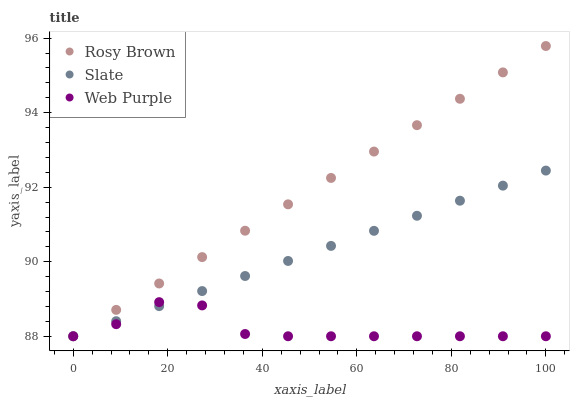Does Web Purple have the minimum area under the curve?
Answer yes or no. Yes. Does Rosy Brown have the maximum area under the curve?
Answer yes or no. Yes. Does Rosy Brown have the minimum area under the curve?
Answer yes or no. No. Does Web Purple have the maximum area under the curve?
Answer yes or no. No. Is Rosy Brown the smoothest?
Answer yes or no. Yes. Is Web Purple the roughest?
Answer yes or no. Yes. Is Web Purple the smoothest?
Answer yes or no. No. Is Rosy Brown the roughest?
Answer yes or no. No. Does Slate have the lowest value?
Answer yes or no. Yes. Does Rosy Brown have the highest value?
Answer yes or no. Yes. Does Web Purple have the highest value?
Answer yes or no. No. Does Rosy Brown intersect Web Purple?
Answer yes or no. Yes. Is Rosy Brown less than Web Purple?
Answer yes or no. No. Is Rosy Brown greater than Web Purple?
Answer yes or no. No. 